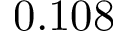<formula> <loc_0><loc_0><loc_500><loc_500>0 . 1 0 8</formula> 